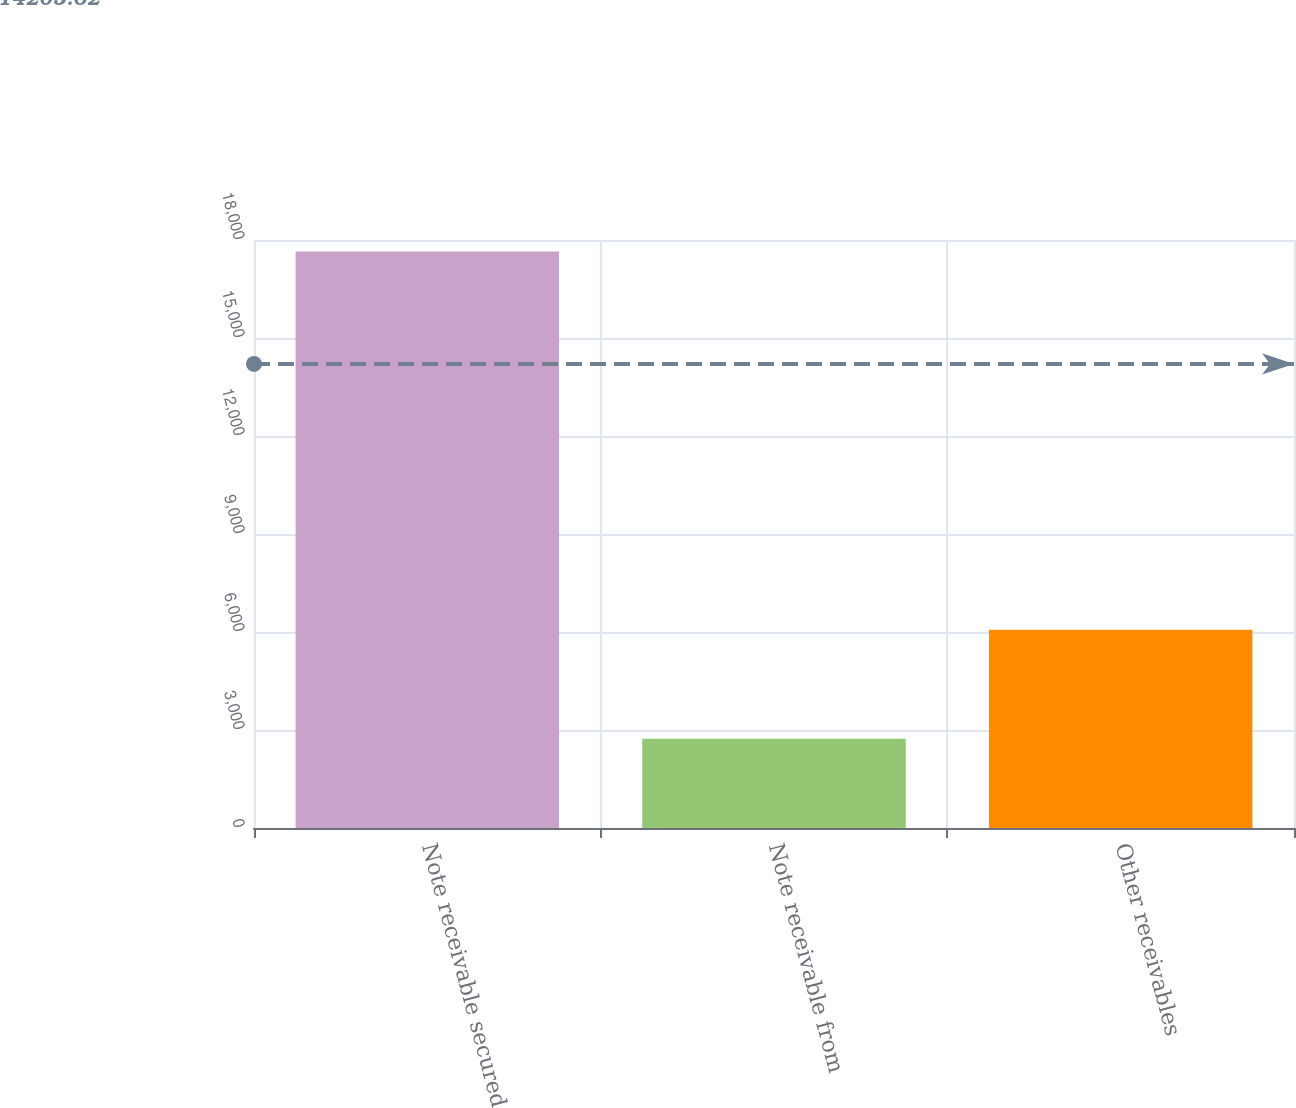<chart> <loc_0><loc_0><loc_500><loc_500><bar_chart><fcel>Note receivable secured<fcel>Note receivable from<fcel>Other receivables<nl><fcel>17646<fcel>2734<fcel>6069<nl></chart> 